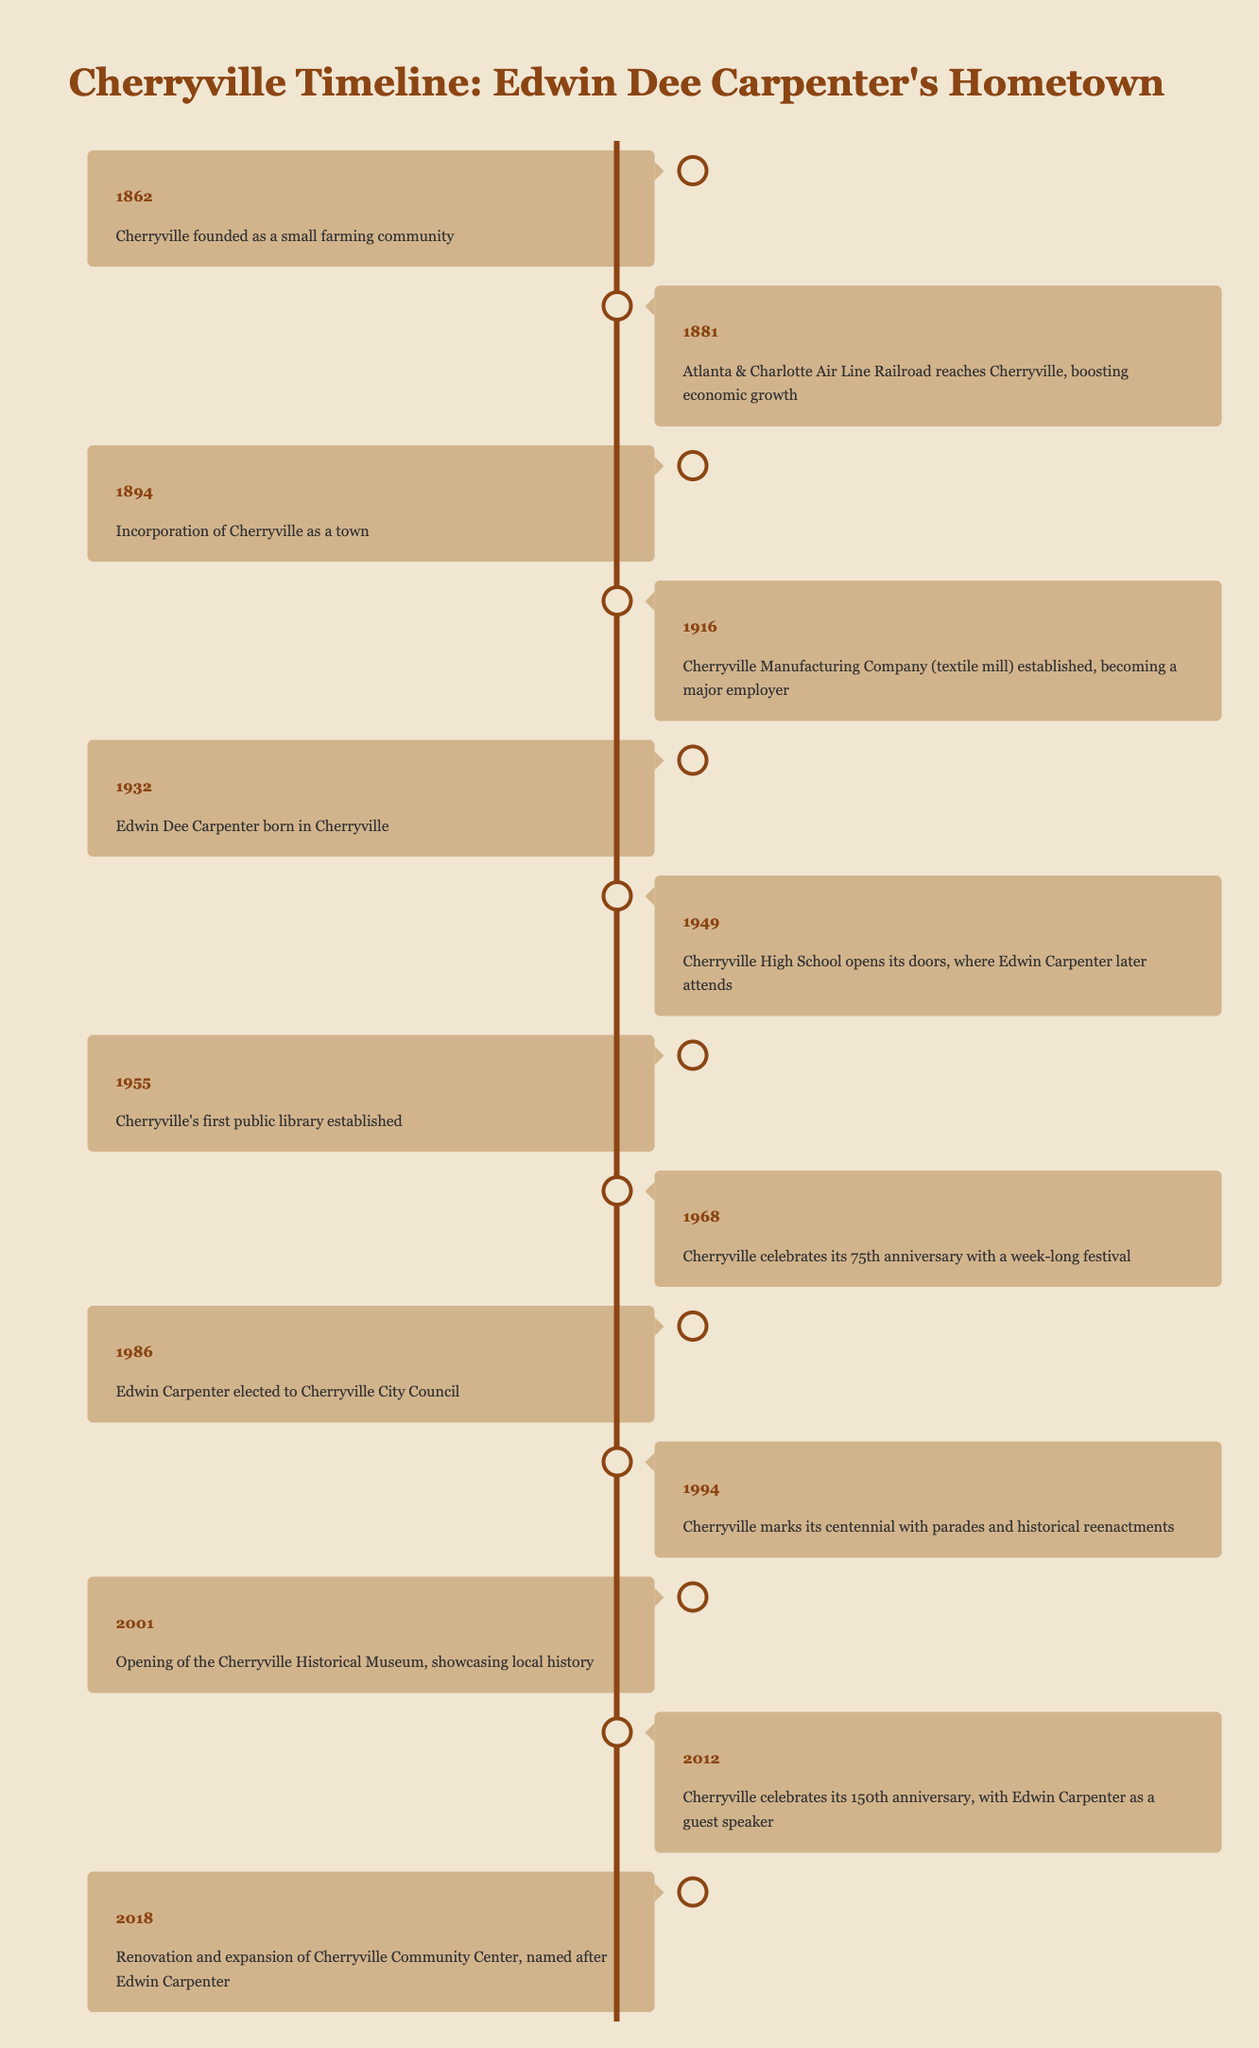What year was Cherryville founded? The timeline shows that Cherryville was founded in 1862.
Answer: 1862 What event took place in 1949 in Cherryville? According to the timeline, Cherryville High School opened its doors in 1949.
Answer: Cherryville High School opens Did Edwin Dee Carpenter serve on the Cherryville City Council? The timeline indicates that Edwin Carpenter was elected to the Cherryville City Council in 1986, confirming he did serve.
Answer: Yes In what year was the Cherryville Historical Museum opened? The timeline lists the opening of the Cherryville Historical Museum as occurring in 2001.
Answer: 2001 How many years after Cherryville’s founding did it celebrate its 75th anniversary? Cherryville was founded in 1862 and celebrated its 75th anniversary in 1968. The difference is 1968 - 1862 = 106 years.
Answer: 106 years What significant event occurred in Cherryville in 1916? The timeline specifies that in 1916, the Cherryville Manufacturing Company was established, making it a major employer in the area.
Answer: Cherryville Manufacturing Company established Was there a public library established in Cherryville before 1960? The timeline indicates that Cherryville's first public library was established in 1955, which is before 1960, confirming the statement.
Answer: Yes What were the two major events happening in the 1990s in Cherryville? In the 1990s, two important events recorded in the timeline were Edwin Carpenter being elected to the City Council in 1986 and Cherryville marking its centennial in 1994.
Answer: Elected to City Council and centennial celebration How many years passed between the founding of Cherryville and its incorporation as a town? Cherryville was founded in 1862 and incorporated in 1894. The years between these two events can be calculated: 1894 - 1862 = 32 years.
Answer: 32 years 